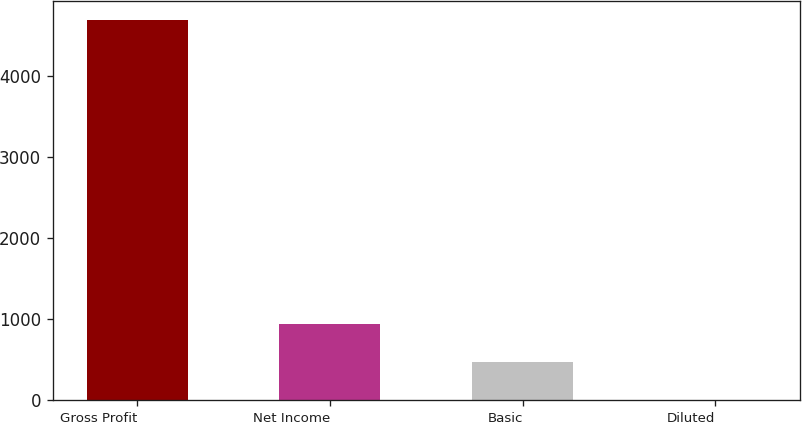<chart> <loc_0><loc_0><loc_500><loc_500><bar_chart><fcel>Gross Profit<fcel>Net Income<fcel>Basic<fcel>Diluted<nl><fcel>4695<fcel>941.67<fcel>472.51<fcel>3.35<nl></chart> 